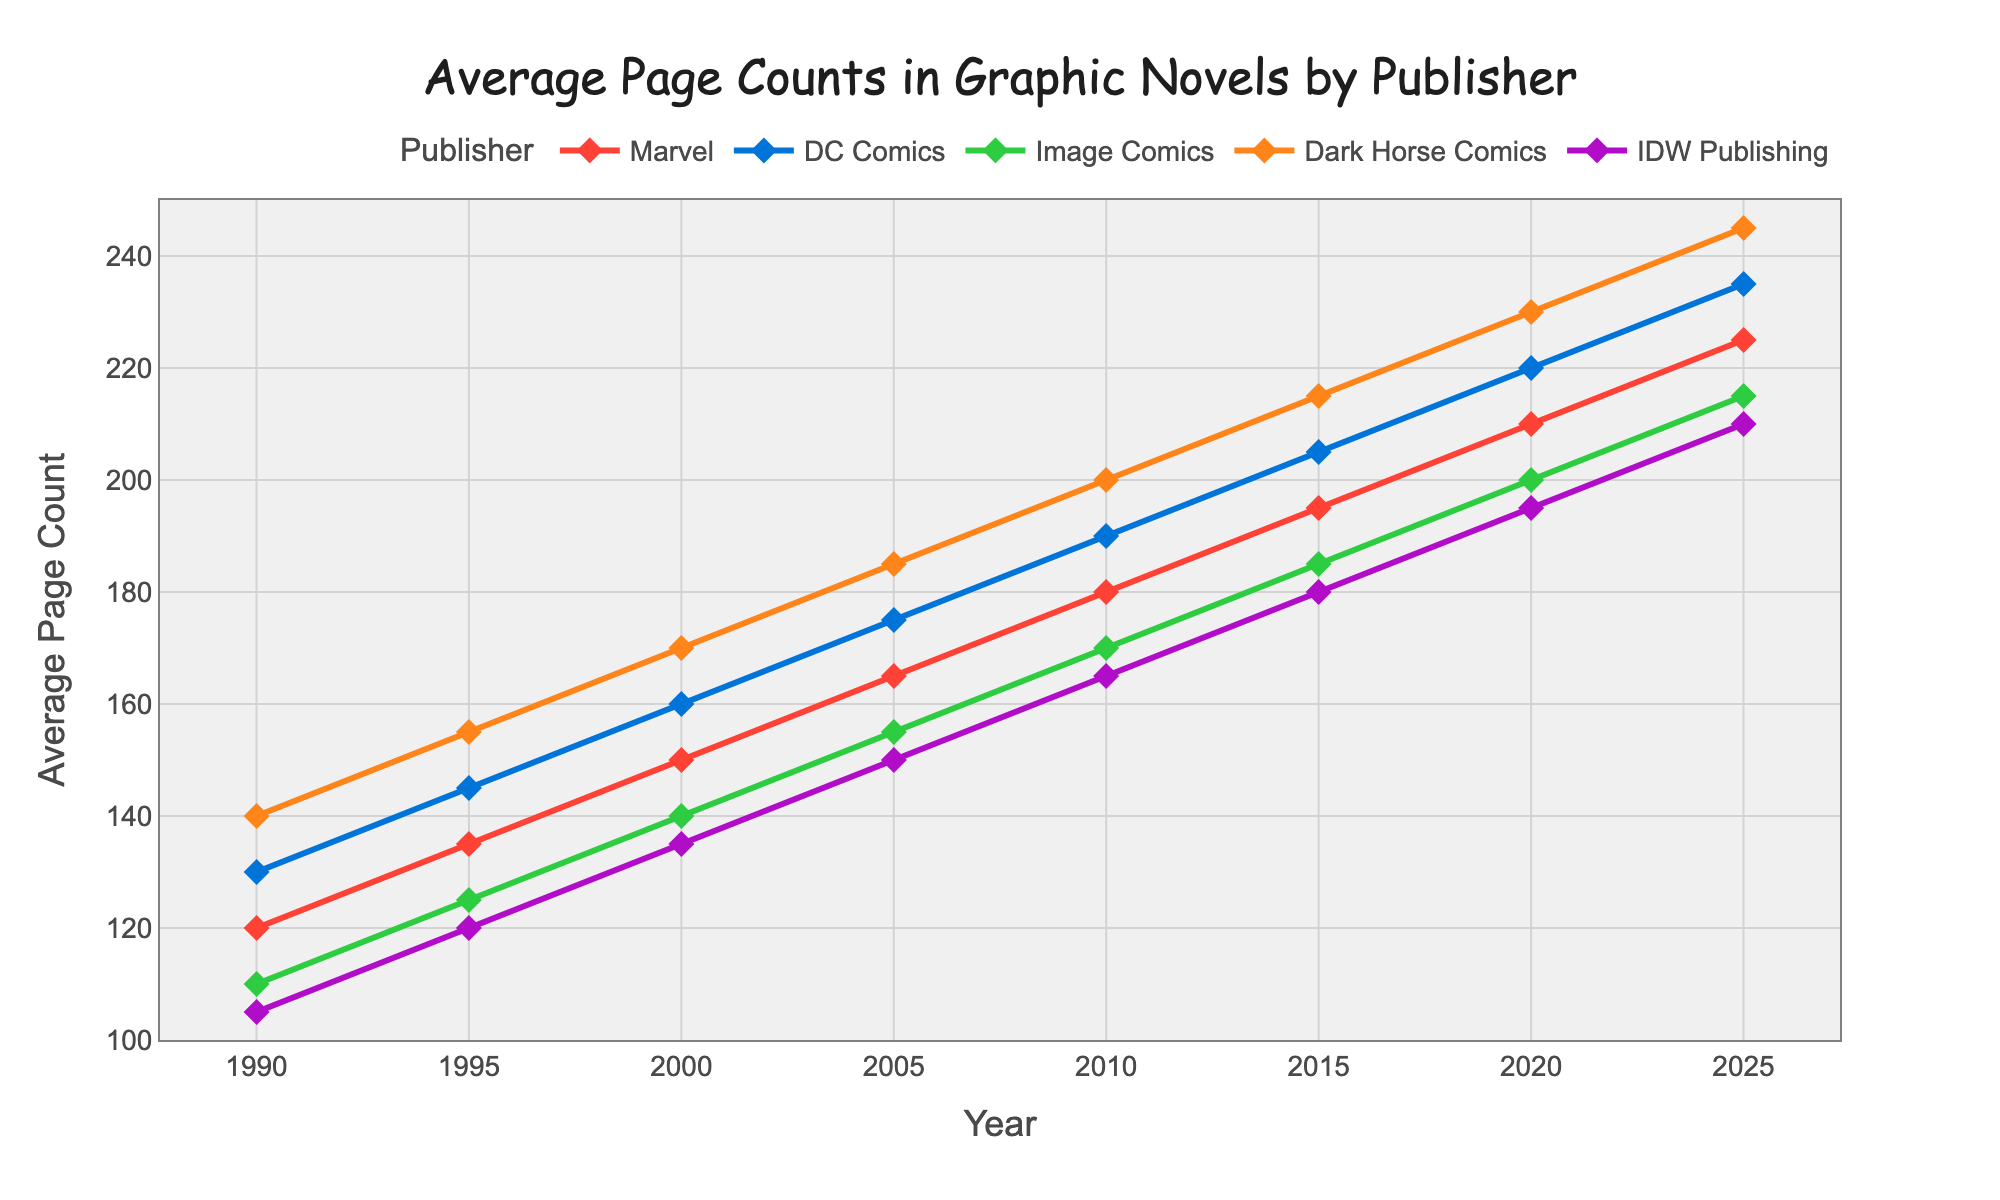What's the average page count for Marvel and DC Comics in 1995? The page count for Marvel in 1995 is 135 and for DC Comics is 145. Add them together (135 + 145 = 280) and then divide by 2 to get the average. The average is 280 / 2 = 140.
Answer: 140 Which publisher had the highest average page count in 2020? In 2020, the page counts for the publishers are: Marvel 210, DC Comics 220, Image Comics 200, Dark Horse Comics 230, IDW Publishing 195. Dark Horse Comics has the highest value, which is 230.
Answer: Dark Horse Comics Compare the trend between Marvel and Image Comics over time. How do they differ from 1990 to 2025? Both Marvel and Image Comics show an increasing trend from 1990 to 2025. However, Marvel starts at 120 in 1990 and reaches 225 in 2025, while Image Comics starts at 110 and reaches 215. Marvel always maintains a higher page count than Image Comics over the years.
Answer: Marvel consistently has higher page counts What is the difference in average page count between Dark Horse Comics and IDW Publishing in 2015? In 2015, Dark Horse Comics has an average page count of 215 and IDW Publishing has 180. Subtract the page count of IDW Publishing from Dark Horse Comics: 215 - 180 = 35.
Answer: 35 Which publisher showed the highest increase in average page count from 1990 to 2025? To find the highest increase, subtract the page count in 1990 from the page count in 2025 for each publisher. Marvel: 225 - 120 = 105, DC Comics: 235 - 130 = 105, Image Comics: 215 - 110 = 105, Dark Horse Comics: 245 - 140 = 105, IDW Publishing: 210 - 105 = 105. All publishers increased similarly by 105 pages.
Answer: All publishers increased by 105 pages In which year did Marvel's average page count reach 180? Look along the line representing Marvel to find when it reaches 180. It reaches 180 in the year 2010.
Answer: 2010 Which publisher had a lower average page count than Image Comics in 2000? In 2000, Image Comics has an average page count of 140. Only IDW Publishing has a lower average page count of 135.
Answer: IDW Publishing What is the sum of average page counts for all publishers in 2005? Add the average page counts for each publisher in 2005: Marvel 165 + DC Comics 175 + Image Comics 155 + Dark Horse Comics 185 + IDW Publishing 150. 165 + 175 + 155 + 185 + 150 = 830.
Answer: 830 Do Marvel and DC Comics ever have the same average page count? By visually inspecting the lines, we notice they do not intersect at any point from 1990 to 2025. Therefore, Marvel and DC Comics never have the same average page count in this period.
Answer: No 